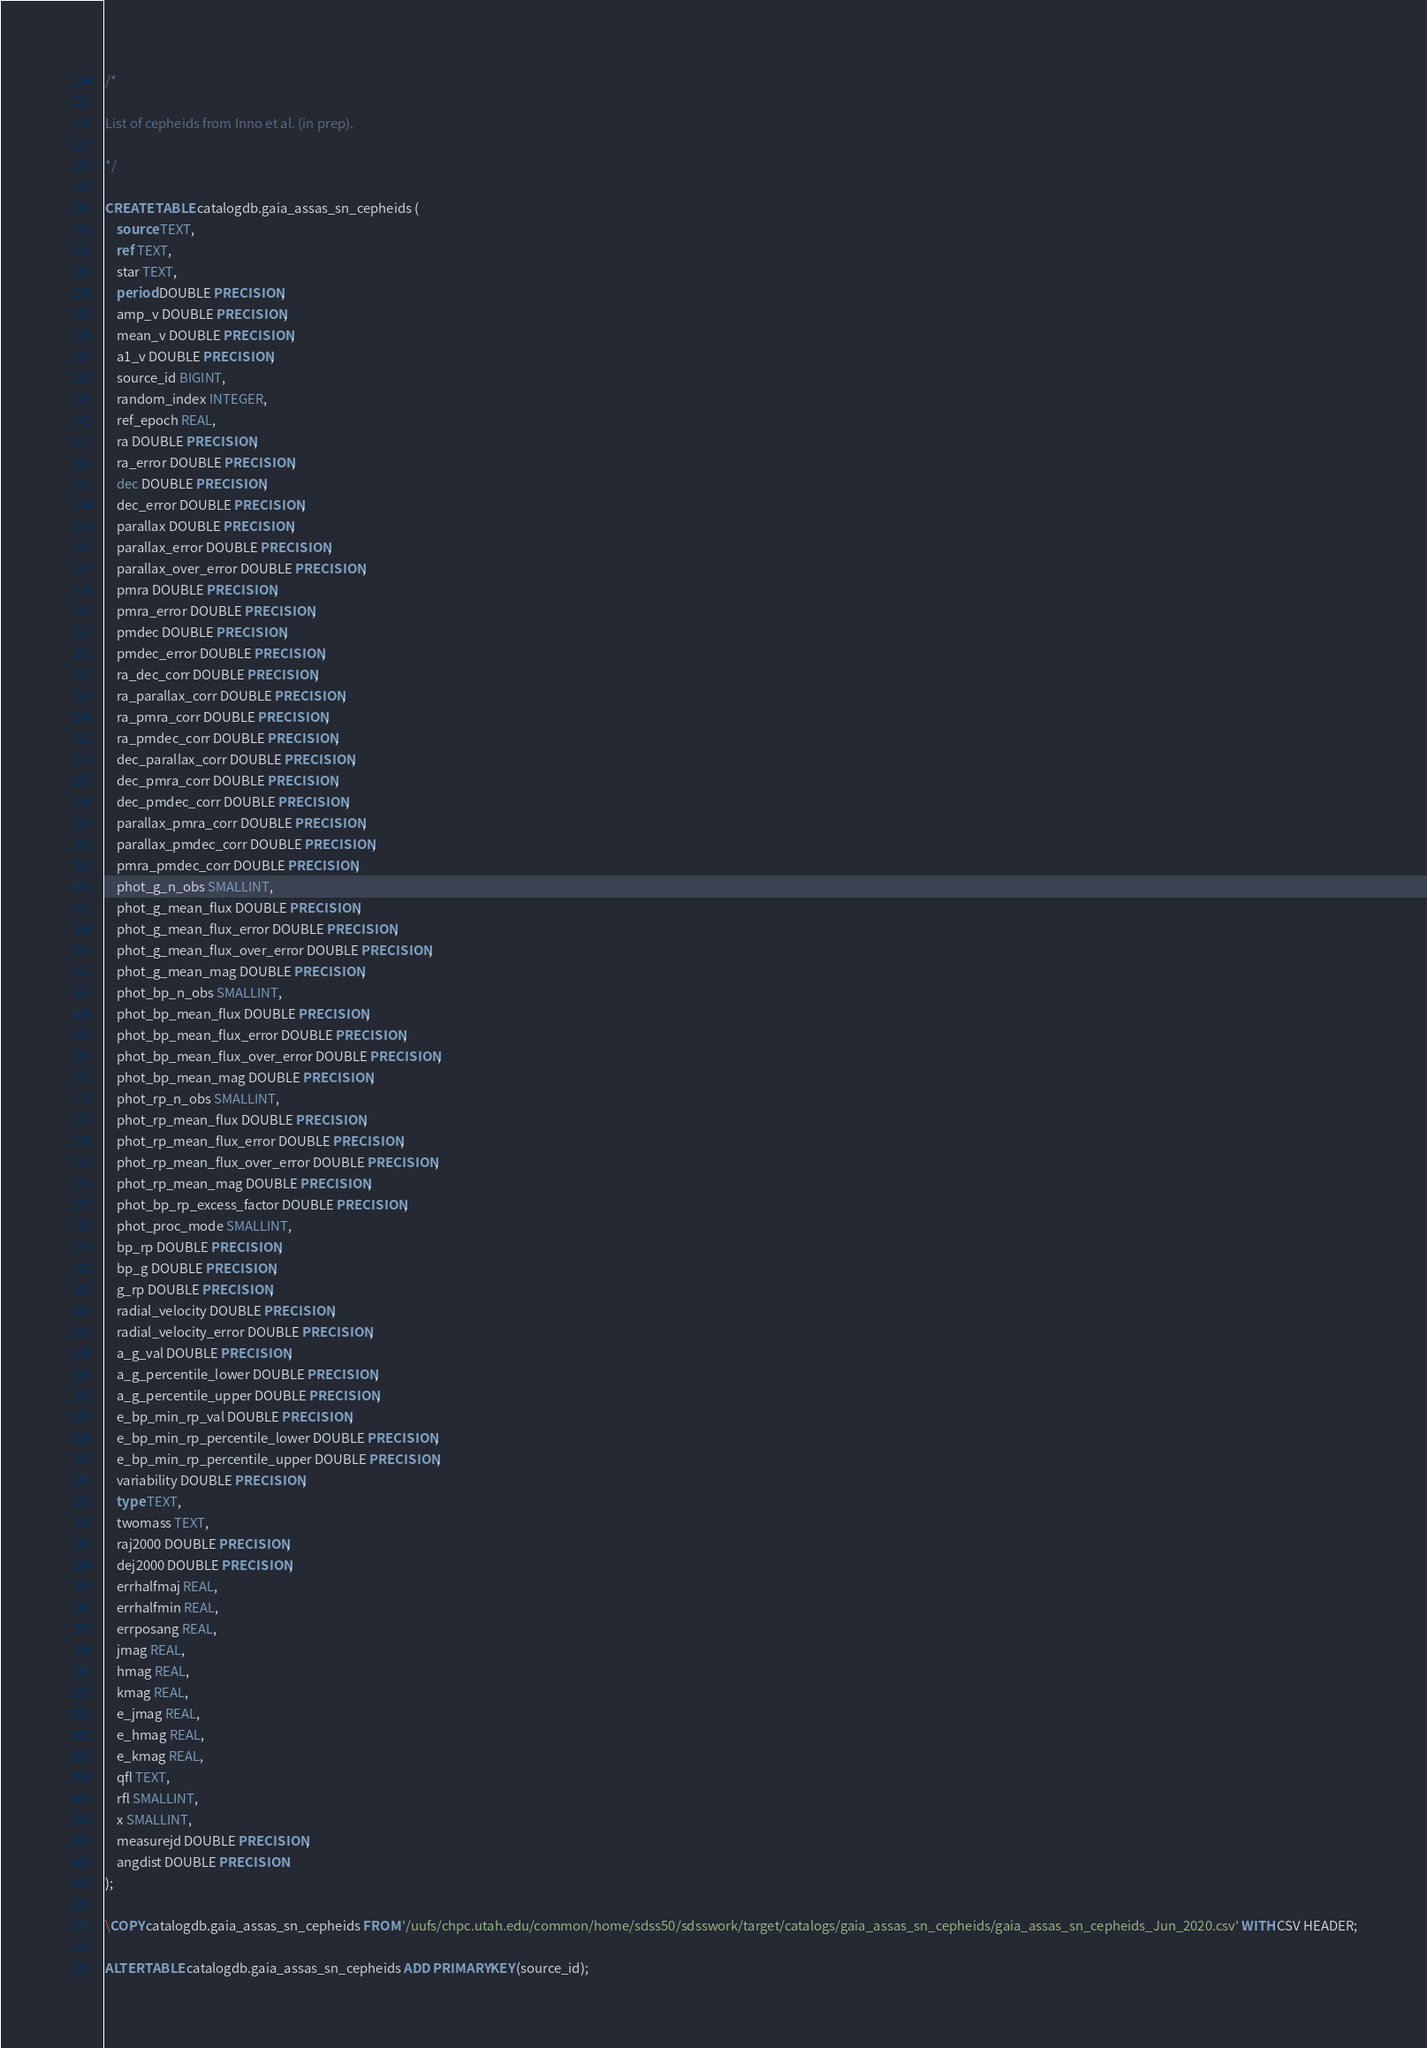Convert code to text. <code><loc_0><loc_0><loc_500><loc_500><_SQL_>/*

List of cepheids from Inno et al. (in prep).

*/

CREATE TABLE catalogdb.gaia_assas_sn_cepheids (
    source TEXT,
    ref TEXT,
    star TEXT,
    period DOUBLE PRECISION,
    amp_v DOUBLE PRECISION,
    mean_v DOUBLE PRECISION,
    a1_v DOUBLE PRECISION,
    source_id BIGINT,
    random_index INTEGER,
    ref_epoch REAL,
    ra DOUBLE PRECISION,
    ra_error DOUBLE PRECISION,
    dec DOUBLE PRECISION,
    dec_error DOUBLE PRECISION,
    parallax DOUBLE PRECISION,
    parallax_error DOUBLE PRECISION,
    parallax_over_error DOUBLE PRECISION,
    pmra DOUBLE PRECISION,
    pmra_error DOUBLE PRECISION,
    pmdec DOUBLE PRECISION,
    pmdec_error DOUBLE PRECISION,
    ra_dec_corr DOUBLE PRECISION,
    ra_parallax_corr DOUBLE PRECISION,
    ra_pmra_corr DOUBLE PRECISION,
    ra_pmdec_corr DOUBLE PRECISION,
    dec_parallax_corr DOUBLE PRECISION,
    dec_pmra_corr DOUBLE PRECISION,
    dec_pmdec_corr DOUBLE PRECISION,
    parallax_pmra_corr DOUBLE PRECISION,
    parallax_pmdec_corr DOUBLE PRECISION,
    pmra_pmdec_corr DOUBLE PRECISION,
    phot_g_n_obs SMALLINT,
    phot_g_mean_flux DOUBLE PRECISION,
    phot_g_mean_flux_error DOUBLE PRECISION,
    phot_g_mean_flux_over_error DOUBLE PRECISION,
    phot_g_mean_mag DOUBLE PRECISION,
    phot_bp_n_obs SMALLINT,
    phot_bp_mean_flux DOUBLE PRECISION,
    phot_bp_mean_flux_error DOUBLE PRECISION,
    phot_bp_mean_flux_over_error DOUBLE PRECISION,
    phot_bp_mean_mag DOUBLE PRECISION,
    phot_rp_n_obs SMALLINT,
    phot_rp_mean_flux DOUBLE PRECISION,
    phot_rp_mean_flux_error DOUBLE PRECISION,
    phot_rp_mean_flux_over_error DOUBLE PRECISION,
    phot_rp_mean_mag DOUBLE PRECISION,
    phot_bp_rp_excess_factor DOUBLE PRECISION,
    phot_proc_mode SMALLINT,
    bp_rp DOUBLE PRECISION,
    bp_g DOUBLE PRECISION,
    g_rp DOUBLE PRECISION,
    radial_velocity DOUBLE PRECISION,
    radial_velocity_error DOUBLE PRECISION,
    a_g_val DOUBLE PRECISION,
    a_g_percentile_lower DOUBLE PRECISION,
    a_g_percentile_upper DOUBLE PRECISION,
    e_bp_min_rp_val DOUBLE PRECISION,
    e_bp_min_rp_percentile_lower DOUBLE PRECISION,
    e_bp_min_rp_percentile_upper DOUBLE PRECISION,
    variability DOUBLE PRECISION,
    type TEXT,
    twomass TEXT,
    raj2000 DOUBLE PRECISION,
    dej2000 DOUBLE PRECISION,
    errhalfmaj REAL,
    errhalfmin REAL,
    errposang REAL,
    jmag REAL,
    hmag REAL,
    kmag REAL,
    e_jmag REAL,
    e_hmag REAL,
    e_kmag REAL,
    qfl TEXT,
    rfl SMALLINT,
    x SMALLINT,
    measurejd DOUBLE PRECISION,
    angdist DOUBLE PRECISION
);

\COPY catalogdb.gaia_assas_sn_cepheids FROM '/uufs/chpc.utah.edu/common/home/sdss50/sdsswork/target/catalogs/gaia_assas_sn_cepheids/gaia_assas_sn_cepheids_Jun_2020.csv' WITH CSV HEADER;

ALTER TABLE catalogdb.gaia_assas_sn_cepheids ADD PRIMARY KEY (source_id);
</code> 